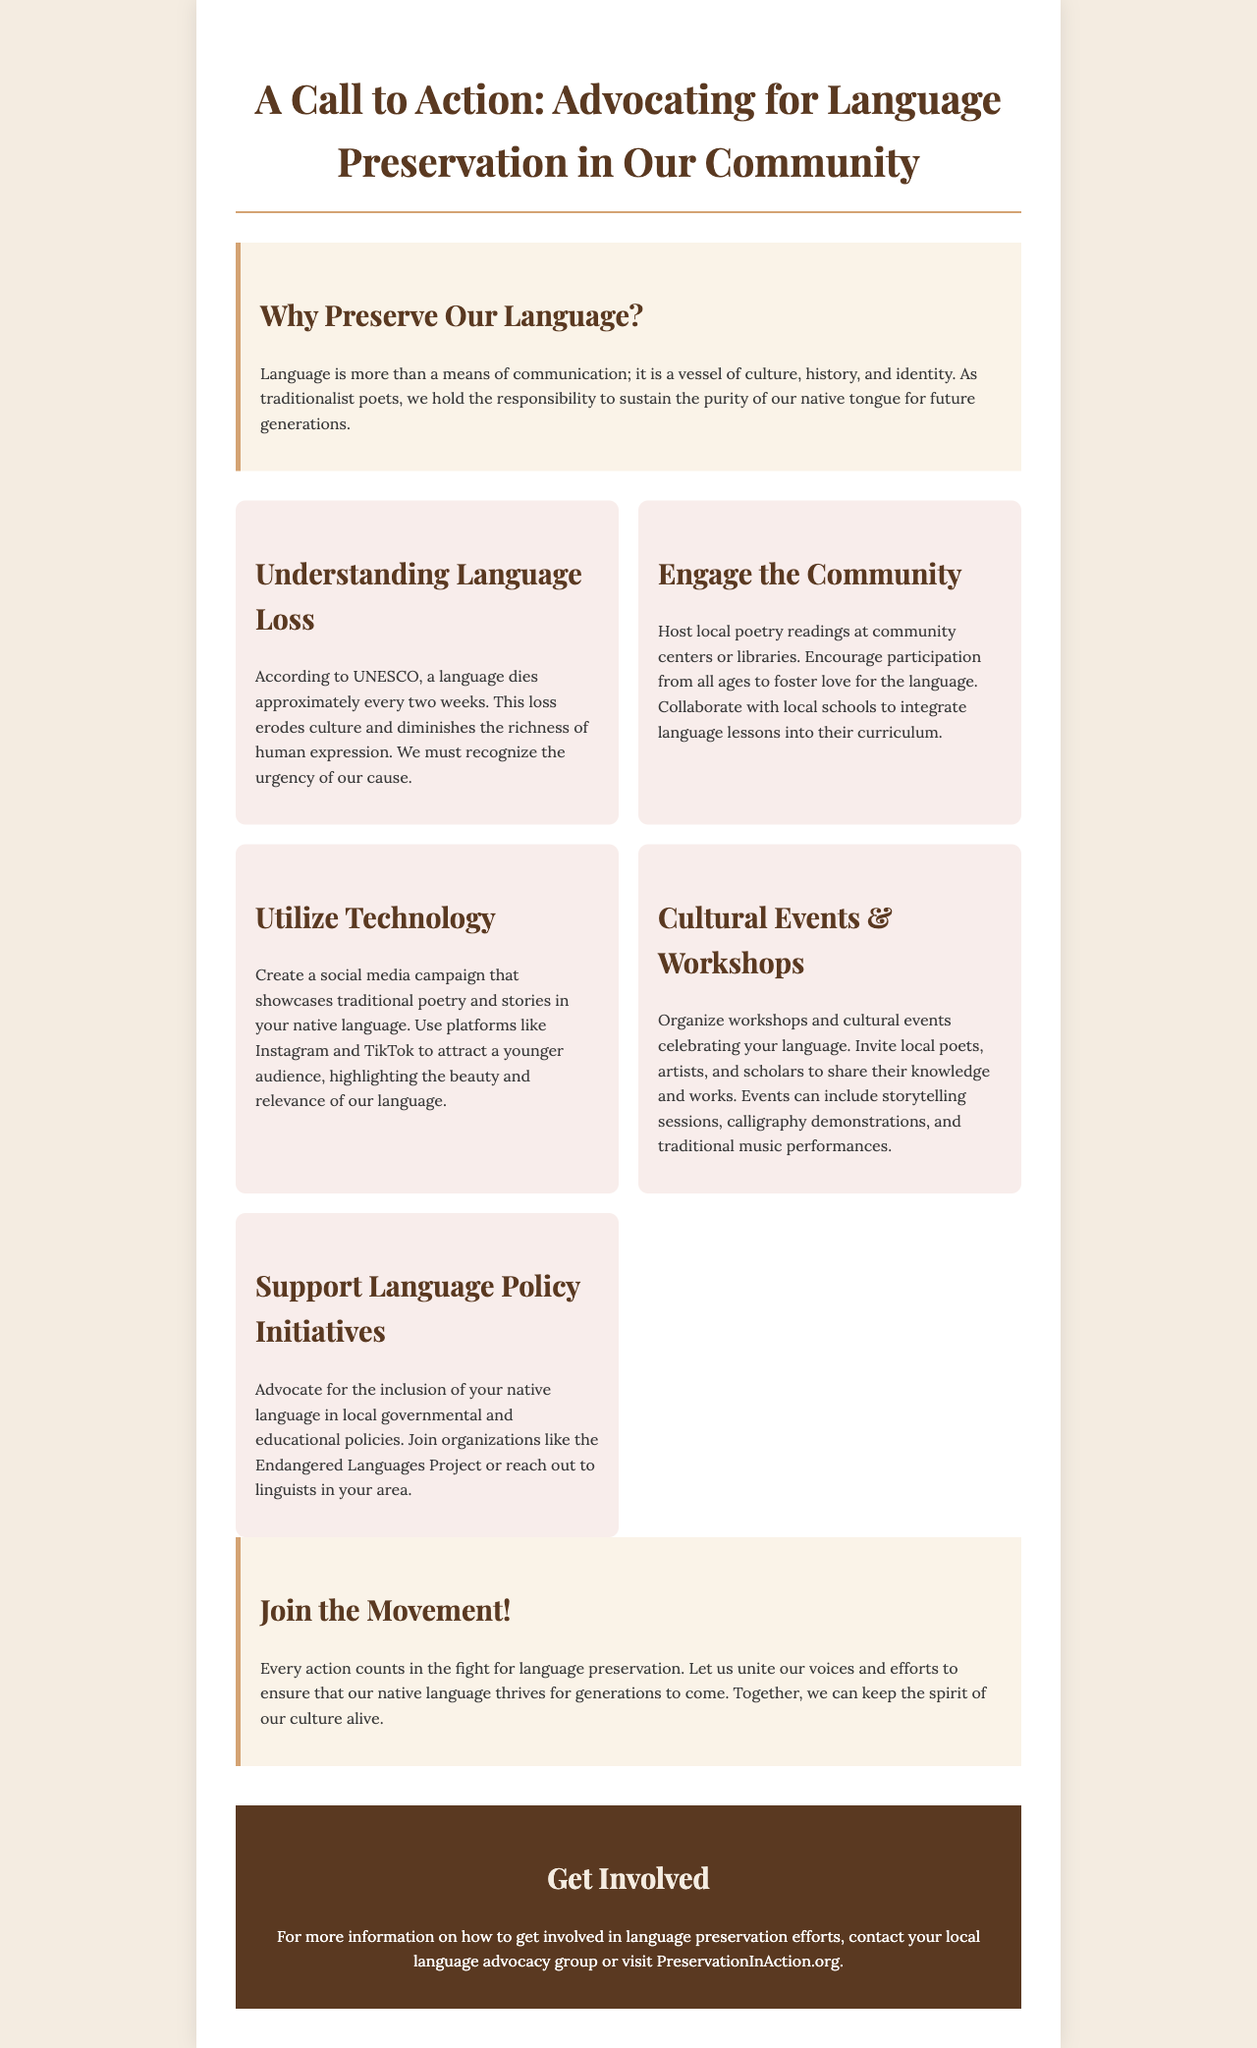What is the title of the brochure? The title is stated at the top of the document and captures the purpose of the content, focusing on language preservation advocacy.
Answer: A Call to Action: Advocating for Language Preservation in Our Community How often does a language die, according to UNESCO? This information is provided in the section detailing the urgency of language loss and its implications for culture.
Answer: Every two weeks What is one way to engage the community? The document shares various suggestions for engaging with the community, specifically highlighting poetry readings and collaboration with schools.
Answer: Host local poetry readings What type of campaign is suggested to attract a younger audience? The brochure mentions an initiative aimed at showcasing traditional poetry and stories on social media platforms designed to engage younger demographics.
Answer: Social media campaign What is one type of event recommended for celebrating language? The brochure provides examples of cultural activities that can be organized to promote the language and its beauty.
Answer: Workshops What is the main call to action in the conclusion? The conclusion emphasizes collective efforts needed to preserve the language for future generations, uniting efforts in a common cause.
Answer: Join the Movement! What should you do to support language policy initiatives? This asks for a specific action individuals can take, as outlined in the document's section about supporting language policy.
Answer: Advocate for inclusion Where can more information about language preservation be found? The contact information section directs readers to a specific website for further details on getting involved in preservation efforts.
Answer: PreservationInAction.org 